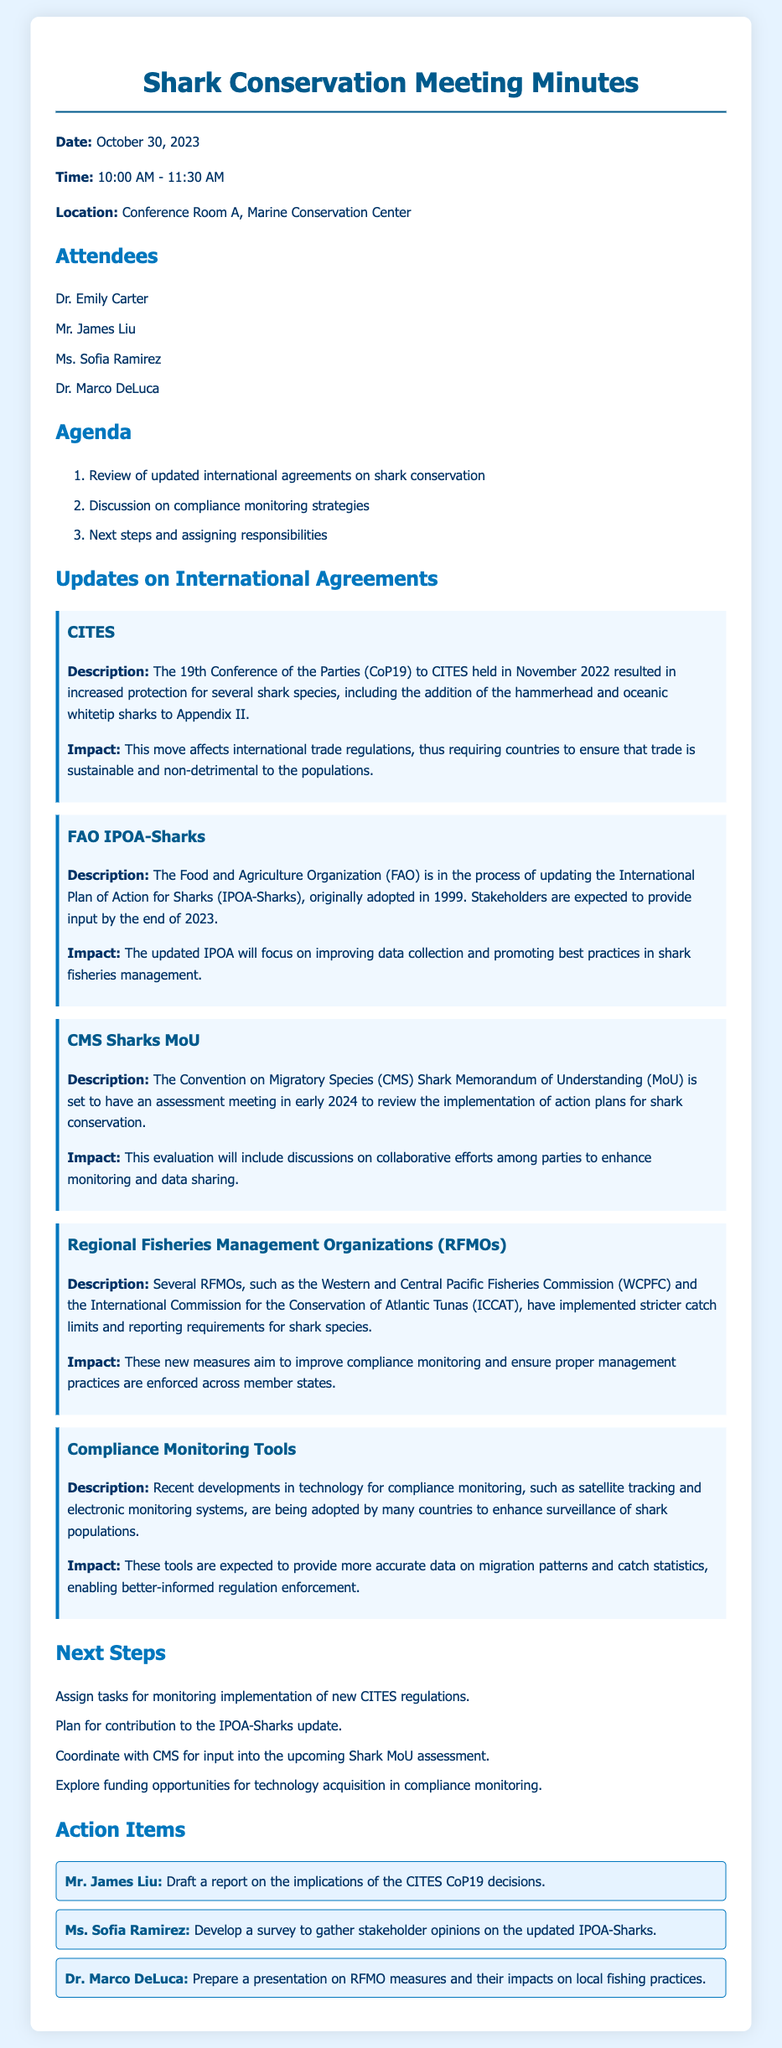What was the date of the meeting? The date of the meeting is stated at the beginning of the document as October 30, 2023.
Answer: October 30, 2023 Who reported on the implications of the CITES CoP19 decisions? This information is noted in the action items section where Mr. James Liu is assigned to draft a report.
Answer: Mr. James Liu What international agreement added the hammerhead and oceanic whitetip sharks to Appendix II? The document specifies that CITES is the agreement that made this addition during CoP19.
Answer: CITES When is the next assessment meeting for the CMS Shark MoU scheduled? The meeting is mentioned to be happening in early 2024.
Answer: Early 2024 What focus will the updated IPOA-Sharks have? The document highlights that the updated IPOA will focus on improving data collection and promoting best practices.
Answer: Improving data collection and promoting best practices How many attendees were present at the meeting? The document lists the names of four attendees in the attendees section.
Answer: Four Which regional fisheries management organizations are mentioned? The document specifically names two organizations: WCPFC and ICCAT.
Answer: WCPFC and ICCAT What was one of the next steps discussed in the meeting? The next steps include tasks like planning for contribution to the IPOA-Sharks update, which is outlined in the next steps section.
Answer: Plan for contribution to the IPOA-Sharks update 